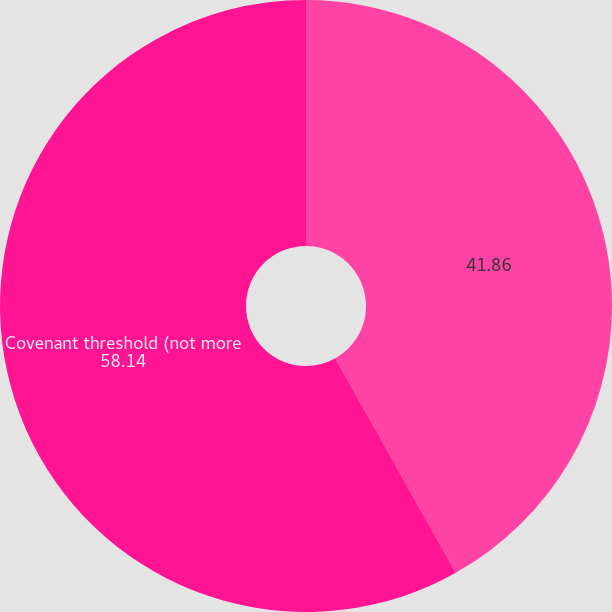Convert chart to OTSL. <chart><loc_0><loc_0><loc_500><loc_500><pie_chart><ecel><fcel>Covenant threshold (not more<nl><fcel>41.86%<fcel>58.14%<nl></chart> 